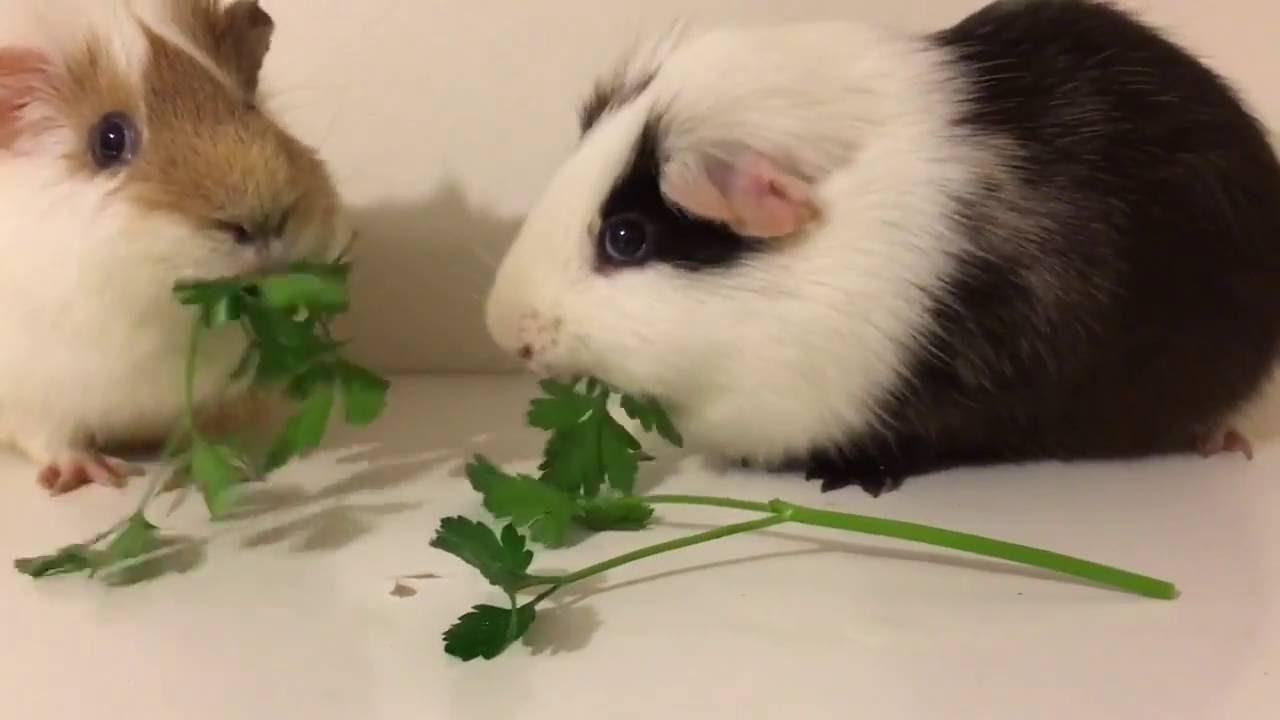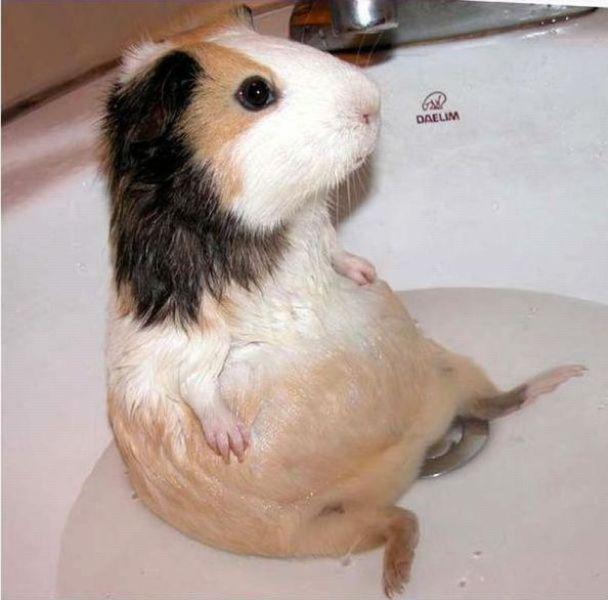The first image is the image on the left, the second image is the image on the right. For the images displayed, is the sentence "One of the images includes part of a human." factually correct? Answer yes or no. No. The first image is the image on the left, the second image is the image on the right. Examine the images to the left and right. Is the description "In one image there are two guinea pigs eating grass." accurate? Answer yes or no. Yes. 